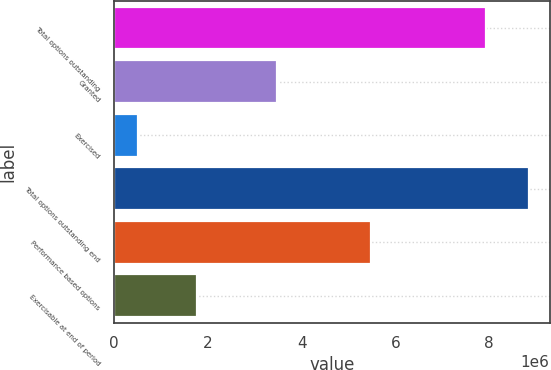Convert chart. <chart><loc_0><loc_0><loc_500><loc_500><bar_chart><fcel>Total options outstanding<fcel>Granted<fcel>Exercised<fcel>Total options outstanding end<fcel>Performance based options<fcel>Exercisable at end of period<nl><fcel>7.92301e+06<fcel>3.46863e+06<fcel>514401<fcel>8.84773e+06<fcel>5.49063e+06<fcel>1.77261e+06<nl></chart> 